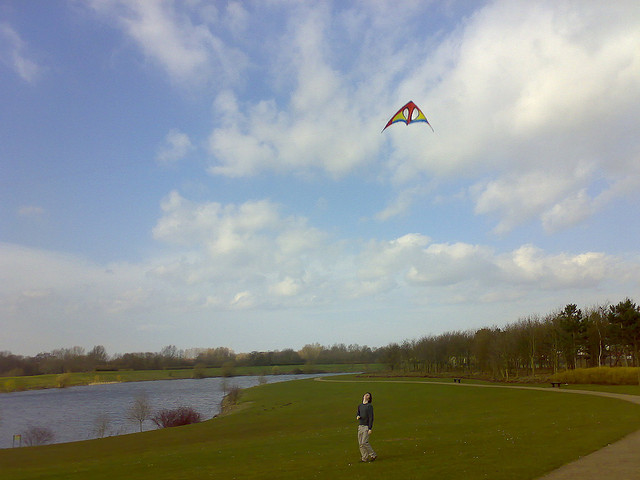Can you describe the landscape in this image? Certainly! The image depicts a peaceful landscape featuring a wide, open grassy field edged by a calm body of water. There are trees lining the horizon, and the sky above is partly cloudy, suggesting a nice day with good weather for outdoor activities. What time of day does it seem to be? Judging by the image, it appears to be midday or early afternoon, as the light is bright and distributed evenly across the landscape with no long shadows that would indicate early morning or late afternoon. 